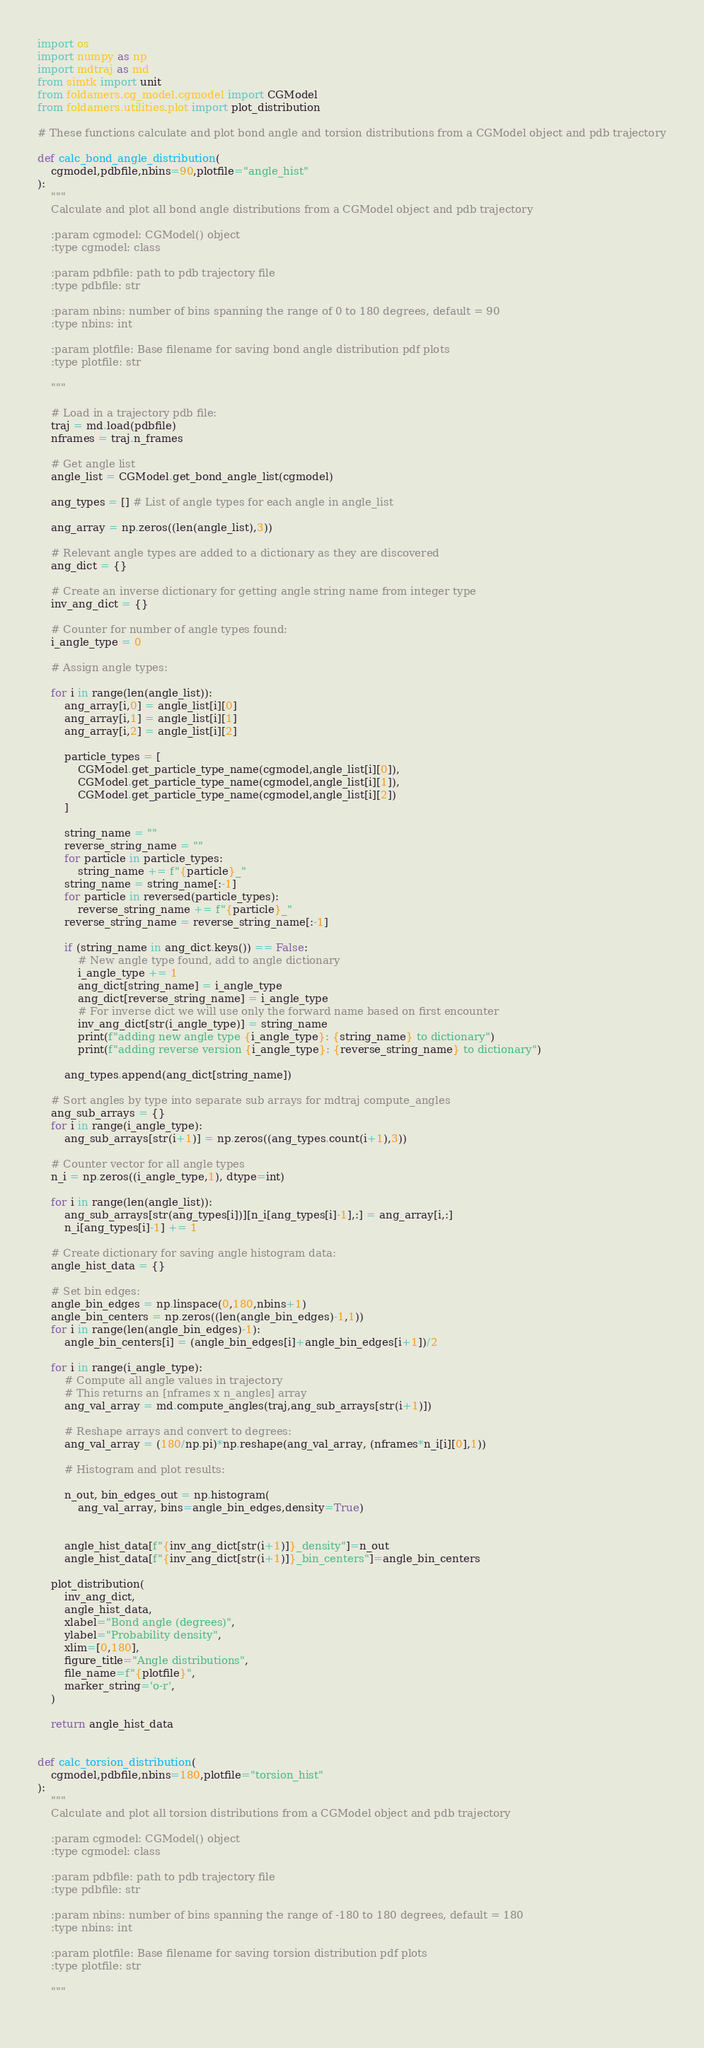Convert code to text. <code><loc_0><loc_0><loc_500><loc_500><_Python_>import os
import numpy as np
import mdtraj as md
from simtk import unit
from foldamers.cg_model.cgmodel import CGModel
from foldamers.utilities.plot import plot_distribution

# These functions calculate and plot bond angle and torsion distributions from a CGModel object and pdb trajectory

def calc_bond_angle_distribution(
    cgmodel,pdbfile,nbins=90,plotfile="angle_hist"
):
    """
    Calculate and plot all bond angle distributions from a CGModel object and pdb trajectory

    :param cgmodel: CGModel() object
    :type cgmodel: class
    
    :param pdbfile: path to pdb trajectory file
    :type pdbfile: str
    
    :param nbins: number of bins spanning the range of 0 to 180 degrees, default = 90
    :type nbins: int
    
    :param plotfile: Base filename for saving bond angle distribution pdf plots
    :type plotfile: str
    
    """
    
    # Load in a trajectory pdb file:
    traj = md.load(pdbfile)
    nframes = traj.n_frames
    
    # Get angle list
    angle_list = CGModel.get_bond_angle_list(cgmodel)
    
    ang_types = [] # List of angle types for each angle in angle_list
    
    ang_array = np.zeros((len(angle_list),3))
    
    # Relevant angle types are added to a dictionary as they are discovered 
    ang_dict = {}
    
    # Create an inverse dictionary for getting angle string name from integer type
    inv_ang_dict = {}
    
    # Counter for number of angle types found:
    i_angle_type = 0
    
    # Assign angle types:
    
    for i in range(len(angle_list)):
        ang_array[i,0] = angle_list[i][0]
        ang_array[i,1] = angle_list[i][1]
        ang_array[i,2] = angle_list[i][2]
        
        particle_types = [
            CGModel.get_particle_type_name(cgmodel,angle_list[i][0]),
            CGModel.get_particle_type_name(cgmodel,angle_list[i][1]),
            CGModel.get_particle_type_name(cgmodel,angle_list[i][2])
        ]
        
        string_name = ""
        reverse_string_name = ""
        for particle in particle_types:
            string_name += f"{particle}_"
        string_name = string_name[:-1]
        for particle in reversed(particle_types):
            reverse_string_name += f"{particle}_"
        reverse_string_name = reverse_string_name[:-1]
            
        if (string_name in ang_dict.keys()) == False:
            # New angle type found, add to angle dictionary
            i_angle_type += 1
            ang_dict[string_name] = i_angle_type
            ang_dict[reverse_string_name] = i_angle_type
            # For inverse dict we will use only the forward name based on first encounter
            inv_ang_dict[str(i_angle_type)] = string_name
            print(f"adding new angle type {i_angle_type}: {string_name} to dictionary")
            print(f"adding reverse version {i_angle_type}: {reverse_string_name} to dictionary")
            
        ang_types.append(ang_dict[string_name])
                    
    # Sort angles by type into separate sub arrays for mdtraj compute_angles
    ang_sub_arrays = {}
    for i in range(i_angle_type):
        ang_sub_arrays[str(i+1)] = np.zeros((ang_types.count(i+1),3))
    
    # Counter vector for all angle types
    n_i = np.zeros((i_angle_type,1), dtype=int)
    
    for i in range(len(angle_list)):
        ang_sub_arrays[str(ang_types[i])][n_i[ang_types[i]-1],:] = ang_array[i,:]
        n_i[ang_types[i]-1] += 1
         
    # Create dictionary for saving angle histogram data:
    angle_hist_data = {}
    
    # Set bin edges:
    angle_bin_edges = np.linspace(0,180,nbins+1)
    angle_bin_centers = np.zeros((len(angle_bin_edges)-1,1))
    for i in range(len(angle_bin_edges)-1):
        angle_bin_centers[i] = (angle_bin_edges[i]+angle_bin_edges[i+1])/2
            
    for i in range(i_angle_type):
        # Compute all angle values in trajectory
        # This returns an [nframes x n_angles] array
        ang_val_array = md.compute_angles(traj,ang_sub_arrays[str(i+1)])
        
        # Reshape arrays and convert to degrees:  
        ang_val_array = (180/np.pi)*np.reshape(ang_val_array, (nframes*n_i[i][0],1))
        
        # Histogram and plot results:
        
        n_out, bin_edges_out = np.histogram(
            ang_val_array, bins=angle_bin_edges,density=True)
            
        
        angle_hist_data[f"{inv_ang_dict[str(i+1)]}_density"]=n_out
        angle_hist_data[f"{inv_ang_dict[str(i+1)]}_bin_centers"]=angle_bin_centers
        
    plot_distribution(
        inv_ang_dict,
        angle_hist_data,
        xlabel="Bond angle (degrees)",
        ylabel="Probability density",
        xlim=[0,180],
        figure_title="Angle distributions",
        file_name=f"{plotfile}",
        marker_string='o-r',
    )
        
    return angle_hist_data

    
def calc_torsion_distribution(
    cgmodel,pdbfile,nbins=180,plotfile="torsion_hist"
):
    """
    Calculate and plot all torsion distributions from a CGModel object and pdb trajectory

    :param cgmodel: CGModel() object
    :type cgmodel: class
    
    :param pdbfile: path to pdb trajectory file
    :type pdbfile: str
    
    :param nbins: number of bins spanning the range of -180 to 180 degrees, default = 180
    :type nbins: int
    
    :param plotfile: Base filename for saving torsion distribution pdf plots
    :type plotfile: str
    
    """
    </code> 